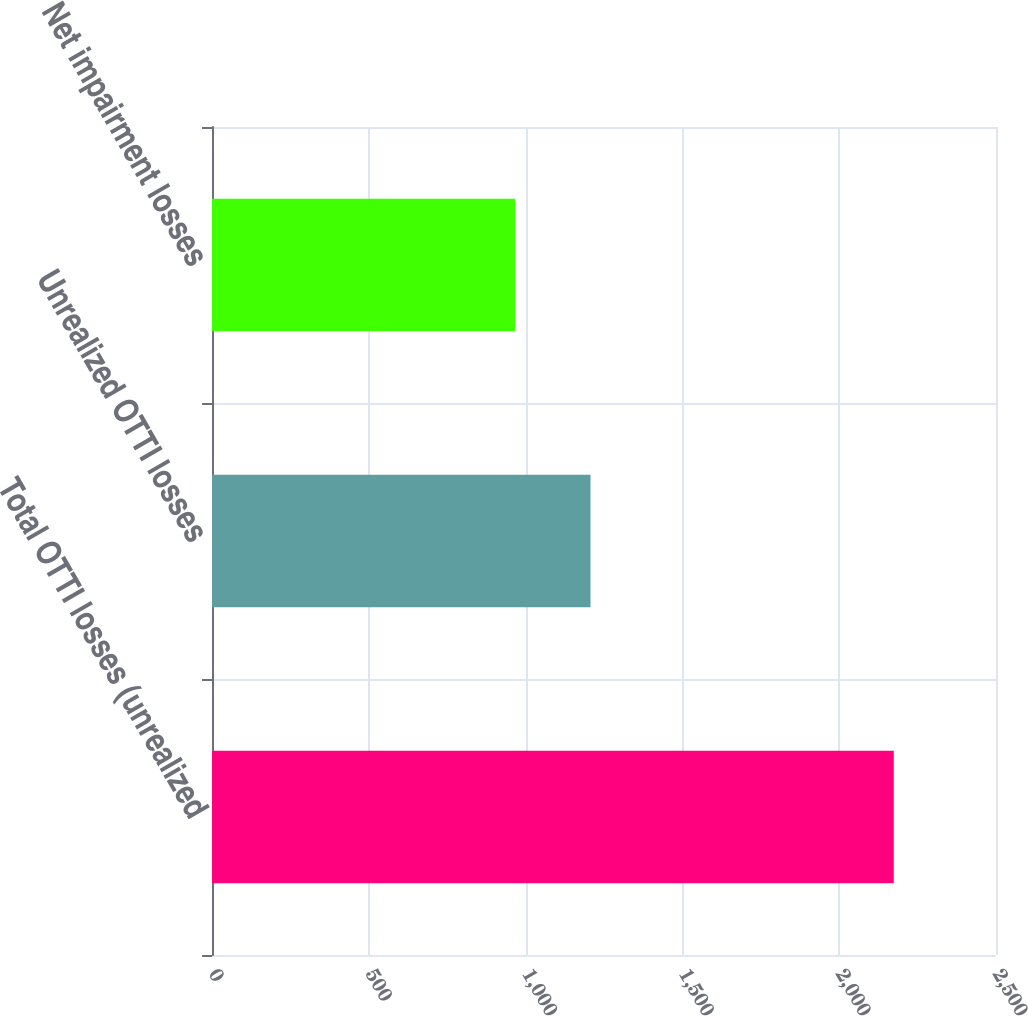<chart> <loc_0><loc_0><loc_500><loc_500><bar_chart><fcel>Total OTTI losses (unrealized<fcel>Unrealized OTTI losses<fcel>Net impairment losses<nl><fcel>2174<fcel>1207<fcel>967<nl></chart> 